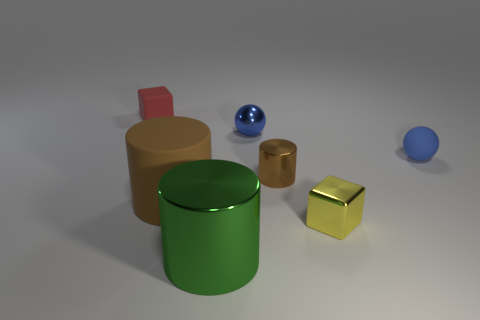What number of large cylinders are made of the same material as the small brown cylinder?
Provide a short and direct response. 1. Do the red matte object and the large thing in front of the brown rubber thing have the same shape?
Give a very brief answer. No. Is there a brown metallic object that is in front of the brown thing that is on the right side of the big cylinder that is to the left of the large green cylinder?
Provide a succinct answer. No. There is a brown thing right of the large green shiny cylinder; how big is it?
Keep it short and to the point. Small. There is a yellow thing that is the same size as the red matte object; what is it made of?
Make the answer very short. Metal. Is the small brown metal thing the same shape as the red object?
Offer a very short reply. No. How many objects are tiny balls or cylinders behind the big green cylinder?
Your answer should be very brief. 4. What material is the other small cylinder that is the same color as the matte cylinder?
Your answer should be very brief. Metal. There is a brown cylinder left of the green thing; is its size the same as the blue metallic sphere?
Provide a succinct answer. No. What number of blocks are behind the tiny matte thing that is to the right of the big object left of the green cylinder?
Ensure brevity in your answer.  1. 